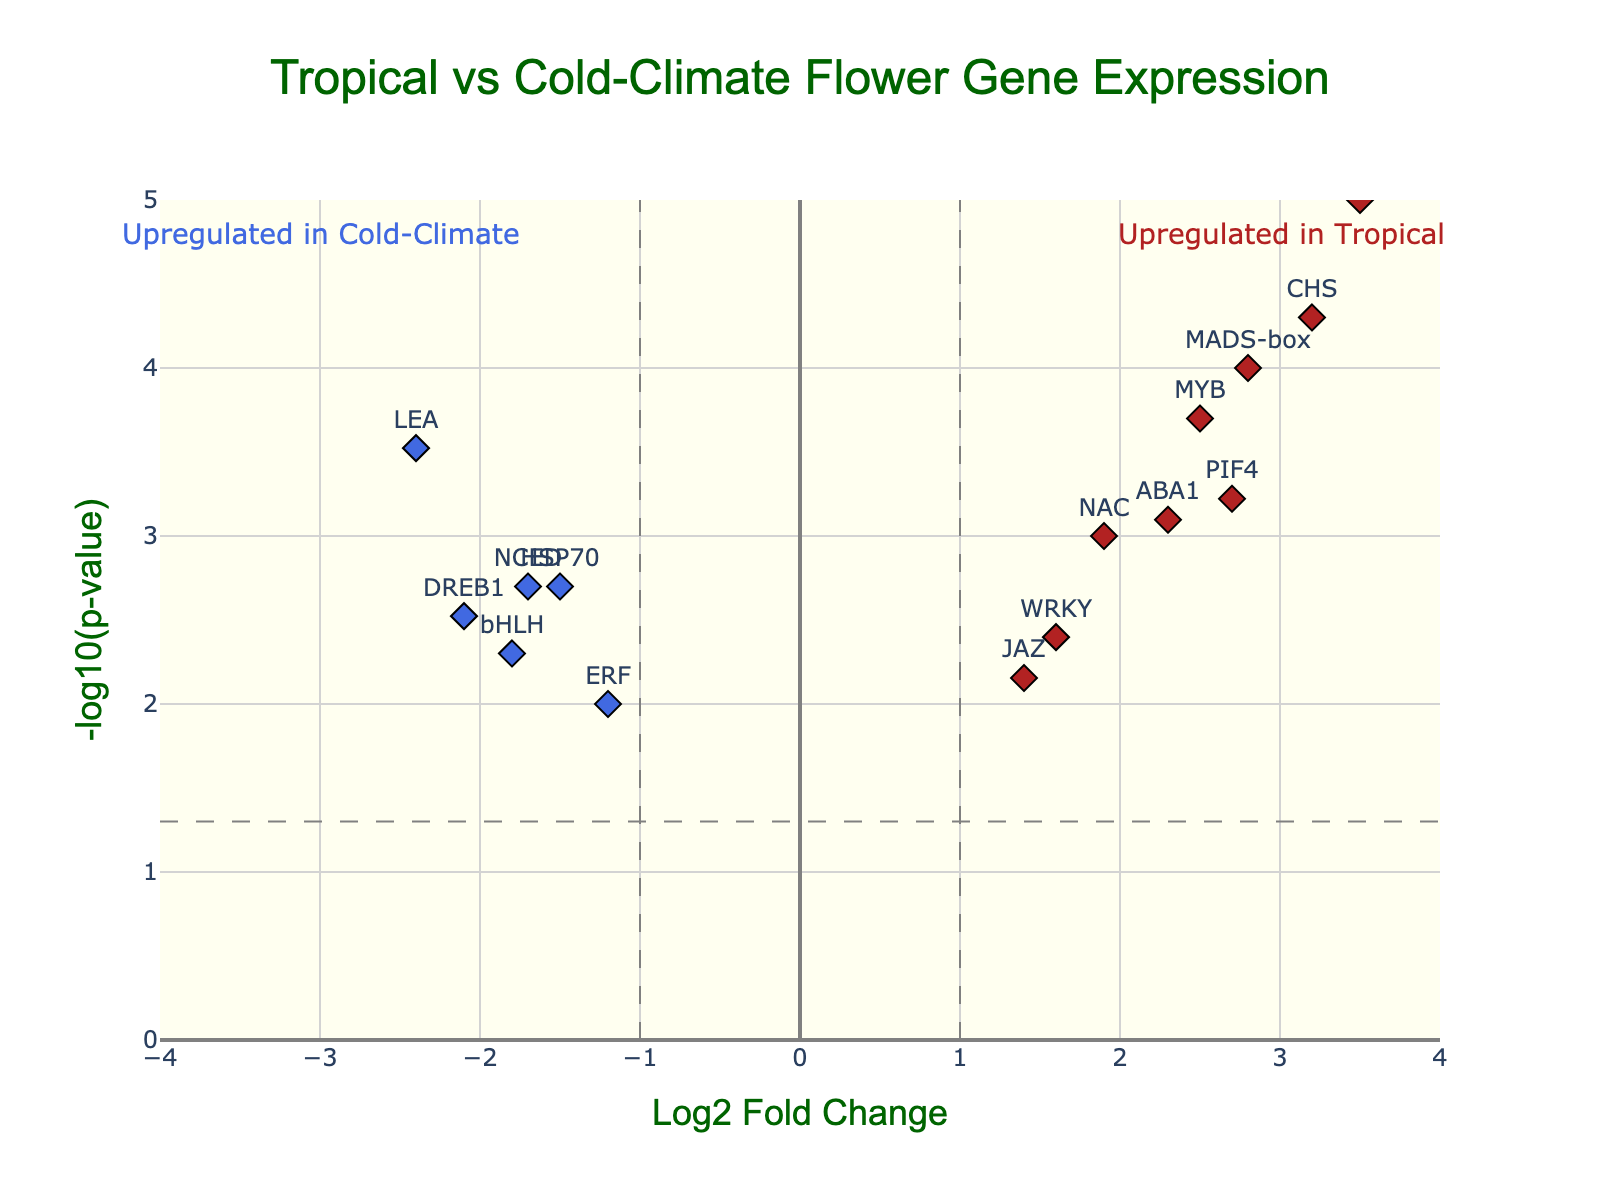What is the title of this plot? The title of the plot is displayed at the top of the figure in a larger font size.
Answer: Tropical vs Cold-Climate Flower Gene Expression What are the values on the x-axis representing? The x-axis values represent Log2 Fold Change, indicating the fold change in gene expression.
Answer: Log2 Fold Change What do the red and blue colors indicate in the plot? The red colors indicate genes significantly upregulated in tropical flowers, and blue colors indicate genes significantly upregulated in cold-climate flowers.
Answer: Red: Upregulated in Tropical, Blue: Upregulated in Cold-Climate Which gene has the highest -log10(p-value)? The gene with the highest y-value (topmost point) in the plot is "CBF," displaying the highest -log10(p-value).
Answer: CBF How many genes are significantly upregulated in tropical flowers? By examining the number of red markers on the right side of the plot with x-values (Log2 Fold Change) greater than 1, we count 6 red markers.
Answer: 6 Which gene has the most extreme downregulation in the cold-climate flowers? The gene with the lowest Log2 Fold Change (most negative x-value) is “LEA” in blue, indicating the most downregulation.
Answer: LEA What is the range of Log2 Fold Change values depicted in the plot? By observing the x-axis, the Log2 Fold Change ranges from -4 to 4.
Answer: -4 to 4 Which genes show both significant and substantial fold change in expression? Significant and substantial changes are shown by markers in red or blue colors, having Log2 Fold Change values above 1 or below -1 and p-values less than 0.05. These genes are: "MADS-box," "CHS," "NAC," "MYB," "ABA1," "CBF," "LEA," and "PIF4" for tropical, and "HSP70," "DREB1," "bHLH," "ERF," and "NCED" for cold-climate.
Answer: MADS-box, CHS, NAC, MYB, ABA1, CBF, LEA, PIF4, HSP70, DREB1, bHLH, ERF, NCED Which gene shows the smallest p-value among those significantly upregulated in tropical flowers? Among the genes upregulated in tropical flowers (red markers on the right), "CHS" has the smallest p-value being the highest marker in this subset.
Answer: CHS Are there any genes that are not significantly different between tropical and cold-climate flowers? Genes depicted as gray markers did not pass the significance threshold for both fold change and p-value. There are 3 such genes.
Answer: Yes, 3 genes 